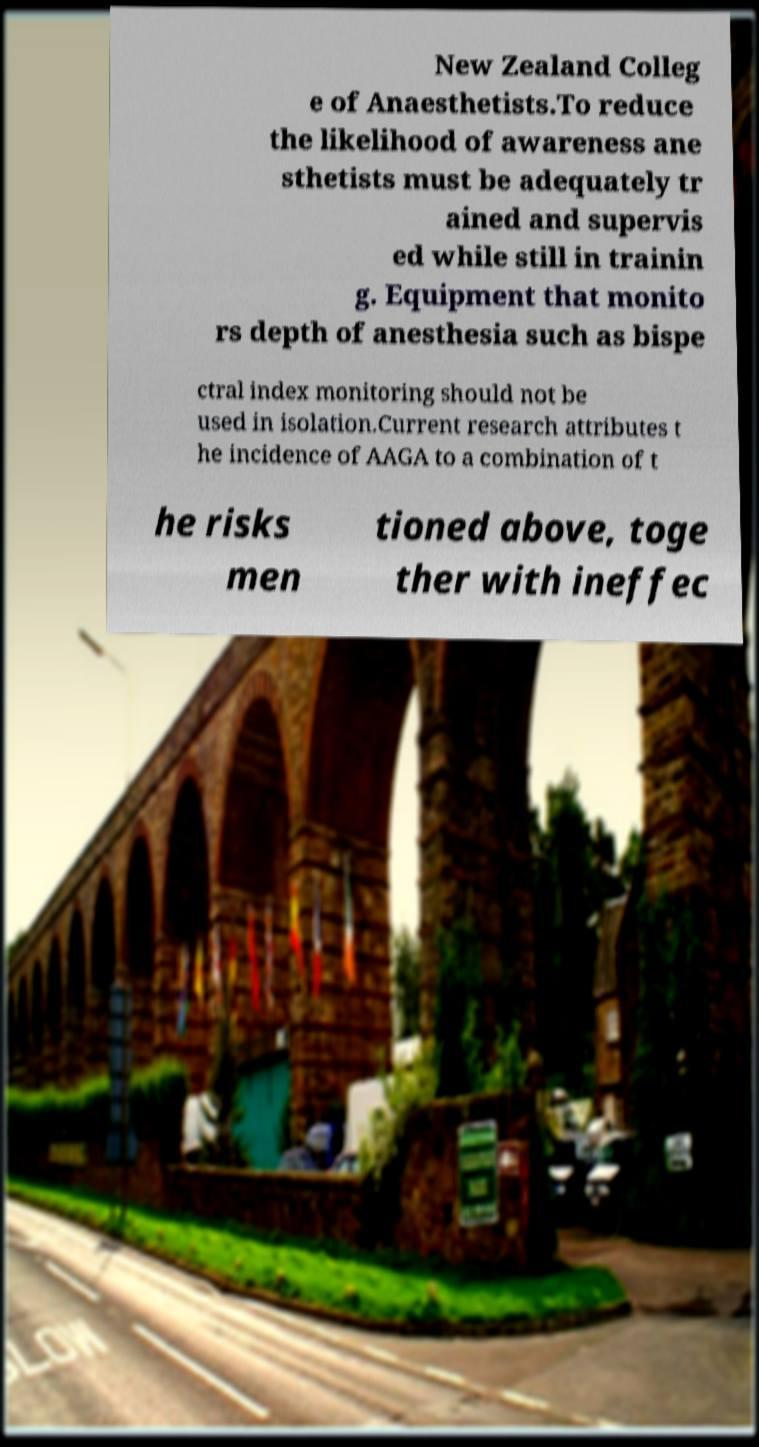There's text embedded in this image that I need extracted. Can you transcribe it verbatim? New Zealand Colleg e of Anaesthetists.To reduce the likelihood of awareness ane sthetists must be adequately tr ained and supervis ed while still in trainin g. Equipment that monito rs depth of anesthesia such as bispe ctral index monitoring should not be used in isolation.Current research attributes t he incidence of AAGA to a combination of t he risks men tioned above, toge ther with ineffec 